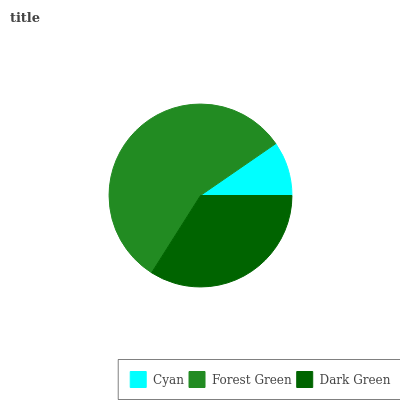Is Cyan the minimum?
Answer yes or no. Yes. Is Forest Green the maximum?
Answer yes or no. Yes. Is Dark Green the minimum?
Answer yes or no. No. Is Dark Green the maximum?
Answer yes or no. No. Is Forest Green greater than Dark Green?
Answer yes or no. Yes. Is Dark Green less than Forest Green?
Answer yes or no. Yes. Is Dark Green greater than Forest Green?
Answer yes or no. No. Is Forest Green less than Dark Green?
Answer yes or no. No. Is Dark Green the high median?
Answer yes or no. Yes. Is Dark Green the low median?
Answer yes or no. Yes. Is Cyan the high median?
Answer yes or no. No. Is Forest Green the low median?
Answer yes or no. No. 